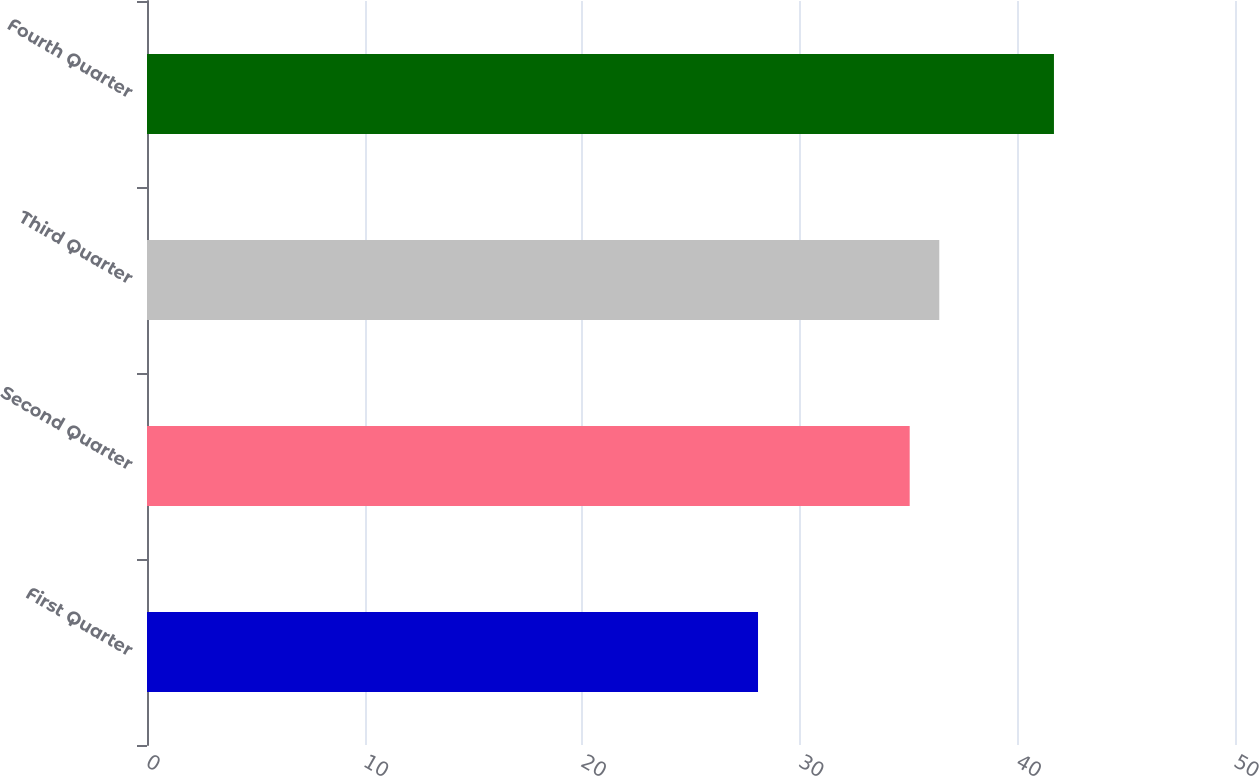Convert chart. <chart><loc_0><loc_0><loc_500><loc_500><bar_chart><fcel>First Quarter<fcel>Second Quarter<fcel>Third Quarter<fcel>Fourth Quarter<nl><fcel>28.08<fcel>35.05<fcel>36.41<fcel>41.68<nl></chart> 